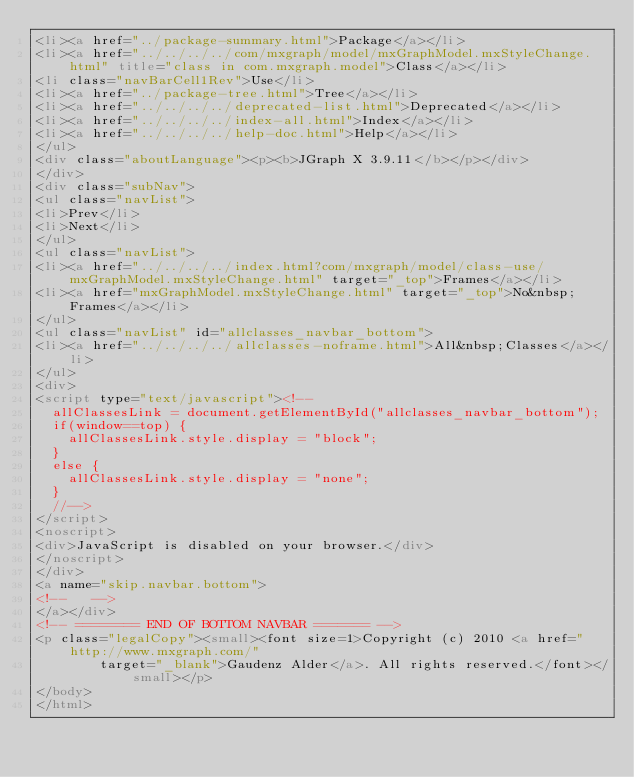<code> <loc_0><loc_0><loc_500><loc_500><_HTML_><li><a href="../package-summary.html">Package</a></li>
<li><a href="../../../../com/mxgraph/model/mxGraphModel.mxStyleChange.html" title="class in com.mxgraph.model">Class</a></li>
<li class="navBarCell1Rev">Use</li>
<li><a href="../package-tree.html">Tree</a></li>
<li><a href="../../../../deprecated-list.html">Deprecated</a></li>
<li><a href="../../../../index-all.html">Index</a></li>
<li><a href="../../../../help-doc.html">Help</a></li>
</ul>
<div class="aboutLanguage"><p><b>JGraph X 3.9.11</b></p></div>
</div>
<div class="subNav">
<ul class="navList">
<li>Prev</li>
<li>Next</li>
</ul>
<ul class="navList">
<li><a href="../../../../index.html?com/mxgraph/model/class-use/mxGraphModel.mxStyleChange.html" target="_top">Frames</a></li>
<li><a href="mxGraphModel.mxStyleChange.html" target="_top">No&nbsp;Frames</a></li>
</ul>
<ul class="navList" id="allclasses_navbar_bottom">
<li><a href="../../../../allclasses-noframe.html">All&nbsp;Classes</a></li>
</ul>
<div>
<script type="text/javascript"><!--
  allClassesLink = document.getElementById("allclasses_navbar_bottom");
  if(window==top) {
    allClassesLink.style.display = "block";
  }
  else {
    allClassesLink.style.display = "none";
  }
  //-->
</script>
<noscript>
<div>JavaScript is disabled on your browser.</div>
</noscript>
</div>
<a name="skip.navbar.bottom">
<!--   -->
</a></div>
<!-- ======== END OF BOTTOM NAVBAR ======= -->
<p class="legalCopy"><small><font size=1>Copyright (c) 2010 <a href="http://www.mxgraph.com/"
				target="_blank">Gaudenz Alder</a>. All rights reserved.</font></small></p>
</body>
</html>
</code> 